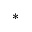Convert formula to latex. <formula><loc_0><loc_0><loc_500><loc_500>^ { * }</formula> 